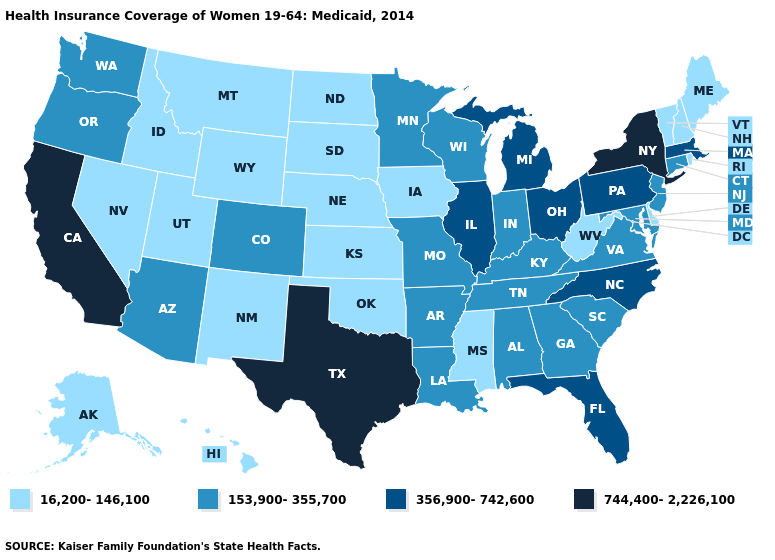Among the states that border New Jersey , does Pennsylvania have the highest value?
Short answer required. No. What is the lowest value in the South?
Give a very brief answer. 16,200-146,100. Among the states that border Mississippi , which have the lowest value?
Keep it brief. Alabama, Arkansas, Louisiana, Tennessee. Does Rhode Island have the lowest value in the Northeast?
Write a very short answer. Yes. Does the first symbol in the legend represent the smallest category?
Answer briefly. Yes. Among the states that border Massachusetts , which have the lowest value?
Keep it brief. New Hampshire, Rhode Island, Vermont. Which states have the lowest value in the USA?
Answer briefly. Alaska, Delaware, Hawaii, Idaho, Iowa, Kansas, Maine, Mississippi, Montana, Nebraska, Nevada, New Hampshire, New Mexico, North Dakota, Oklahoma, Rhode Island, South Dakota, Utah, Vermont, West Virginia, Wyoming. Name the states that have a value in the range 153,900-355,700?
Quick response, please. Alabama, Arizona, Arkansas, Colorado, Connecticut, Georgia, Indiana, Kentucky, Louisiana, Maryland, Minnesota, Missouri, New Jersey, Oregon, South Carolina, Tennessee, Virginia, Washington, Wisconsin. Among the states that border Arizona , does California have the highest value?
Be succinct. Yes. Name the states that have a value in the range 744,400-2,226,100?
Keep it brief. California, New York, Texas. What is the highest value in the West ?
Be succinct. 744,400-2,226,100. Does Rhode Island have the lowest value in the USA?
Keep it brief. Yes. Name the states that have a value in the range 744,400-2,226,100?
Write a very short answer. California, New York, Texas. Does Wisconsin have the same value as Georgia?
Write a very short answer. Yes. Does the first symbol in the legend represent the smallest category?
Give a very brief answer. Yes. 